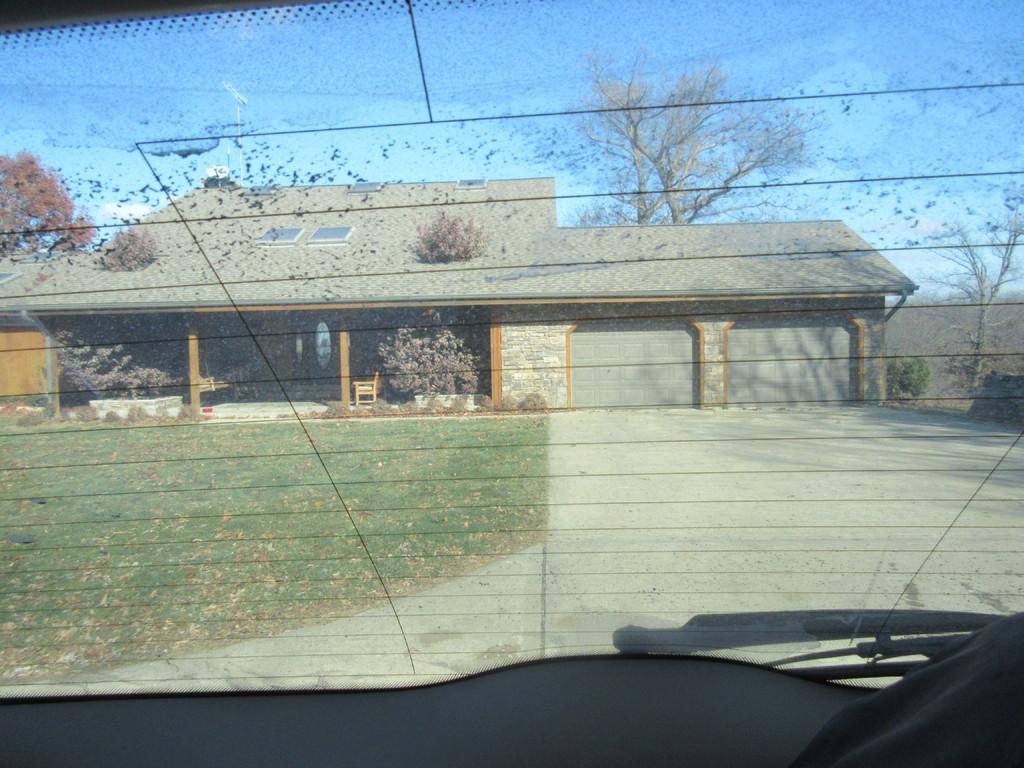How would you summarize this image in a sentence or two? In this image we can see the car back window through which we can see the grass, house, trees and the blue sky in the background. 